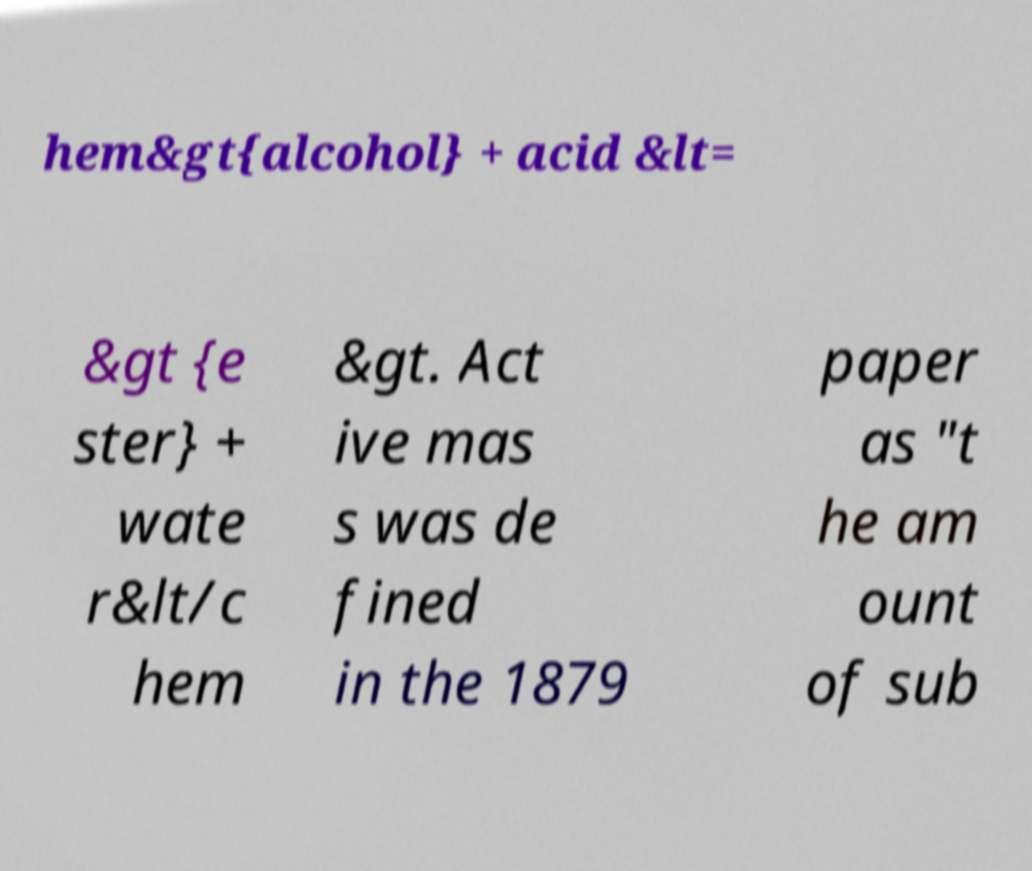Could you assist in decoding the text presented in this image and type it out clearly? hem&gt{alcohol} + acid &lt= &gt {e ster} + wate r&lt/c hem &gt. Act ive mas s was de fined in the 1879 paper as "t he am ount of sub 